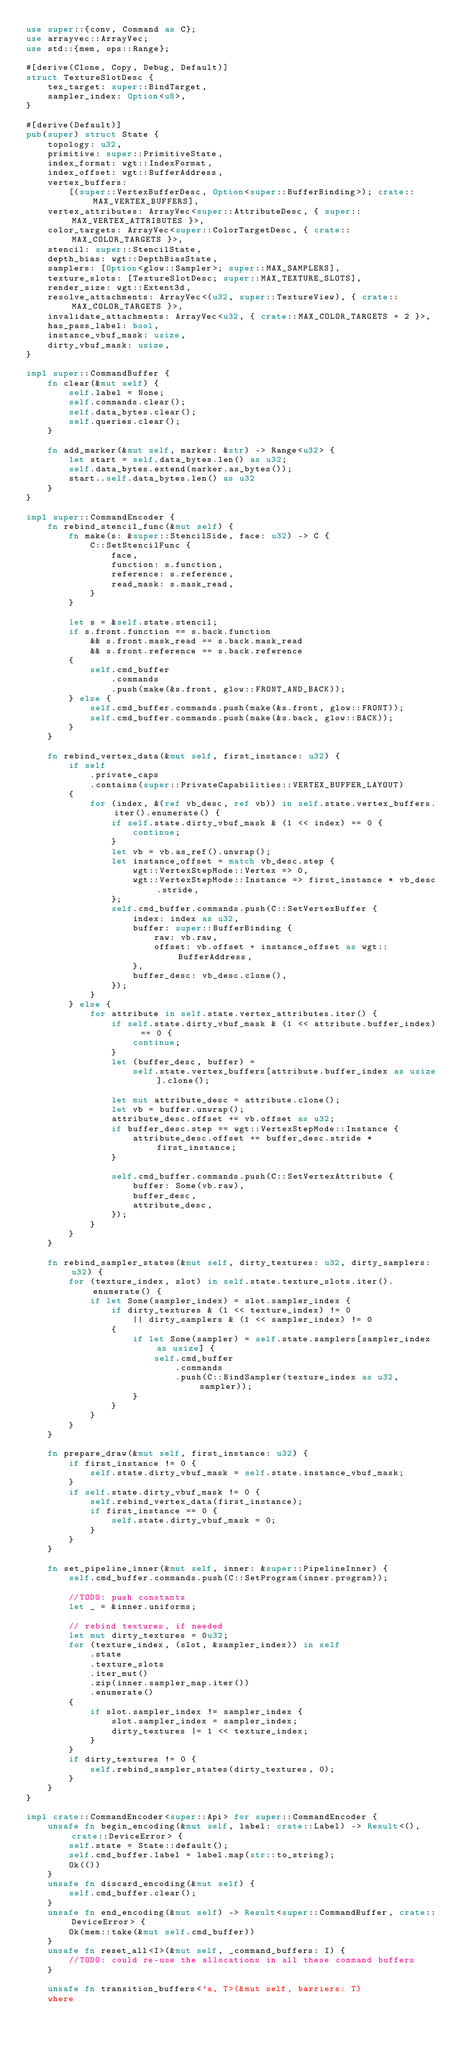<code> <loc_0><loc_0><loc_500><loc_500><_Rust_>use super::{conv, Command as C};
use arrayvec::ArrayVec;
use std::{mem, ops::Range};

#[derive(Clone, Copy, Debug, Default)]
struct TextureSlotDesc {
    tex_target: super::BindTarget,
    sampler_index: Option<u8>,
}

#[derive(Default)]
pub(super) struct State {
    topology: u32,
    primitive: super::PrimitiveState,
    index_format: wgt::IndexFormat,
    index_offset: wgt::BufferAddress,
    vertex_buffers:
        [(super::VertexBufferDesc, Option<super::BufferBinding>); crate::MAX_VERTEX_BUFFERS],
    vertex_attributes: ArrayVec<super::AttributeDesc, { super::MAX_VERTEX_ATTRIBUTES }>,
    color_targets: ArrayVec<super::ColorTargetDesc, { crate::MAX_COLOR_TARGETS }>,
    stencil: super::StencilState,
    depth_bias: wgt::DepthBiasState,
    samplers: [Option<glow::Sampler>; super::MAX_SAMPLERS],
    texture_slots: [TextureSlotDesc; super::MAX_TEXTURE_SLOTS],
    render_size: wgt::Extent3d,
    resolve_attachments: ArrayVec<(u32, super::TextureView), { crate::MAX_COLOR_TARGETS }>,
    invalidate_attachments: ArrayVec<u32, { crate::MAX_COLOR_TARGETS + 2 }>,
    has_pass_label: bool,
    instance_vbuf_mask: usize,
    dirty_vbuf_mask: usize,
}

impl super::CommandBuffer {
    fn clear(&mut self) {
        self.label = None;
        self.commands.clear();
        self.data_bytes.clear();
        self.queries.clear();
    }

    fn add_marker(&mut self, marker: &str) -> Range<u32> {
        let start = self.data_bytes.len() as u32;
        self.data_bytes.extend(marker.as_bytes());
        start..self.data_bytes.len() as u32
    }
}

impl super::CommandEncoder {
    fn rebind_stencil_func(&mut self) {
        fn make(s: &super::StencilSide, face: u32) -> C {
            C::SetStencilFunc {
                face,
                function: s.function,
                reference: s.reference,
                read_mask: s.mask_read,
            }
        }

        let s = &self.state.stencil;
        if s.front.function == s.back.function
            && s.front.mask_read == s.back.mask_read
            && s.front.reference == s.back.reference
        {
            self.cmd_buffer
                .commands
                .push(make(&s.front, glow::FRONT_AND_BACK));
        } else {
            self.cmd_buffer.commands.push(make(&s.front, glow::FRONT));
            self.cmd_buffer.commands.push(make(&s.back, glow::BACK));
        }
    }

    fn rebind_vertex_data(&mut self, first_instance: u32) {
        if self
            .private_caps
            .contains(super::PrivateCapabilities::VERTEX_BUFFER_LAYOUT)
        {
            for (index, &(ref vb_desc, ref vb)) in self.state.vertex_buffers.iter().enumerate() {
                if self.state.dirty_vbuf_mask & (1 << index) == 0 {
                    continue;
                }
                let vb = vb.as_ref().unwrap();
                let instance_offset = match vb_desc.step {
                    wgt::VertexStepMode::Vertex => 0,
                    wgt::VertexStepMode::Instance => first_instance * vb_desc.stride,
                };
                self.cmd_buffer.commands.push(C::SetVertexBuffer {
                    index: index as u32,
                    buffer: super::BufferBinding {
                        raw: vb.raw,
                        offset: vb.offset + instance_offset as wgt::BufferAddress,
                    },
                    buffer_desc: vb_desc.clone(),
                });
            }
        } else {
            for attribute in self.state.vertex_attributes.iter() {
                if self.state.dirty_vbuf_mask & (1 << attribute.buffer_index) == 0 {
                    continue;
                }
                let (buffer_desc, buffer) =
                    self.state.vertex_buffers[attribute.buffer_index as usize].clone();

                let mut attribute_desc = attribute.clone();
                let vb = buffer.unwrap();
                attribute_desc.offset += vb.offset as u32;
                if buffer_desc.step == wgt::VertexStepMode::Instance {
                    attribute_desc.offset += buffer_desc.stride * first_instance;
                }

                self.cmd_buffer.commands.push(C::SetVertexAttribute {
                    buffer: Some(vb.raw),
                    buffer_desc,
                    attribute_desc,
                });
            }
        }
    }

    fn rebind_sampler_states(&mut self, dirty_textures: u32, dirty_samplers: u32) {
        for (texture_index, slot) in self.state.texture_slots.iter().enumerate() {
            if let Some(sampler_index) = slot.sampler_index {
                if dirty_textures & (1 << texture_index) != 0
                    || dirty_samplers & (1 << sampler_index) != 0
                {
                    if let Some(sampler) = self.state.samplers[sampler_index as usize] {
                        self.cmd_buffer
                            .commands
                            .push(C::BindSampler(texture_index as u32, sampler));
                    }
                }
            }
        }
    }

    fn prepare_draw(&mut self, first_instance: u32) {
        if first_instance != 0 {
            self.state.dirty_vbuf_mask = self.state.instance_vbuf_mask;
        }
        if self.state.dirty_vbuf_mask != 0 {
            self.rebind_vertex_data(first_instance);
            if first_instance == 0 {
                self.state.dirty_vbuf_mask = 0;
            }
        }
    }

    fn set_pipeline_inner(&mut self, inner: &super::PipelineInner) {
        self.cmd_buffer.commands.push(C::SetProgram(inner.program));

        //TODO: push constants
        let _ = &inner.uniforms;

        // rebind textures, if needed
        let mut dirty_textures = 0u32;
        for (texture_index, (slot, &sampler_index)) in self
            .state
            .texture_slots
            .iter_mut()
            .zip(inner.sampler_map.iter())
            .enumerate()
        {
            if slot.sampler_index != sampler_index {
                slot.sampler_index = sampler_index;
                dirty_textures |= 1 << texture_index;
            }
        }
        if dirty_textures != 0 {
            self.rebind_sampler_states(dirty_textures, 0);
        }
    }
}

impl crate::CommandEncoder<super::Api> for super::CommandEncoder {
    unsafe fn begin_encoding(&mut self, label: crate::Label) -> Result<(), crate::DeviceError> {
        self.state = State::default();
        self.cmd_buffer.label = label.map(str::to_string);
        Ok(())
    }
    unsafe fn discard_encoding(&mut self) {
        self.cmd_buffer.clear();
    }
    unsafe fn end_encoding(&mut self) -> Result<super::CommandBuffer, crate::DeviceError> {
        Ok(mem::take(&mut self.cmd_buffer))
    }
    unsafe fn reset_all<I>(&mut self, _command_buffers: I) {
        //TODO: could re-use the allocations in all these command buffers
    }

    unsafe fn transition_buffers<'a, T>(&mut self, barriers: T)
    where</code> 